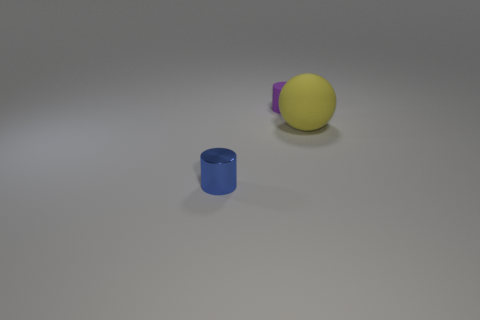Add 3 yellow objects. How many objects exist? 6 Subtract all spheres. How many objects are left? 2 Subtract all blue metallic cylinders. Subtract all tiny blue things. How many objects are left? 1 Add 3 large matte objects. How many large matte objects are left? 4 Add 2 rubber things. How many rubber things exist? 4 Subtract 0 green blocks. How many objects are left? 3 